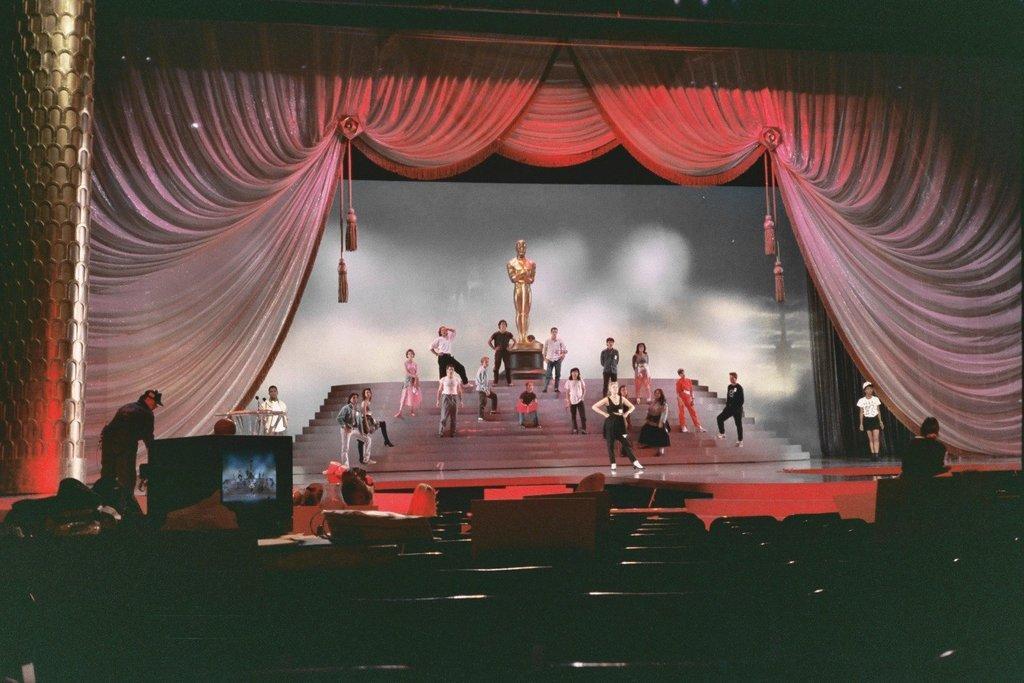Could you give a brief overview of what you see in this image? In front of the image there are a few chairs, in front of the chairs there is an object and there is a person standing, beside him there are some objects on the table. In the background of the image there is a stage, on the stage there are a few people and a depiction of Oscar award are on the stairs. At the top of the stage there is a curtain. Beside the stage there is a pillar. 